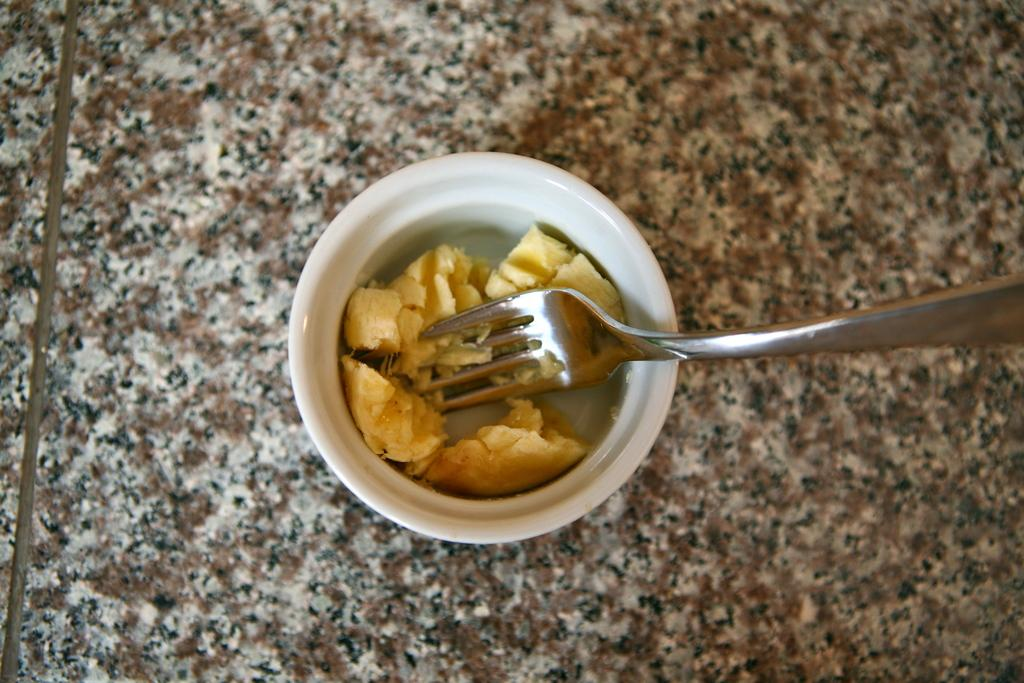What is the color and size of the bowl in the image? The bowl is small and white. What is inside the bowl? The bowl contains food items. What utensil is on the floor in the image? There is a fork on the floor in the image. What type of jam is being served in the metal bowl in the image? There is no jam or metal bowl present in the image; it features a small white bowl with food items and a fork on the floor. 